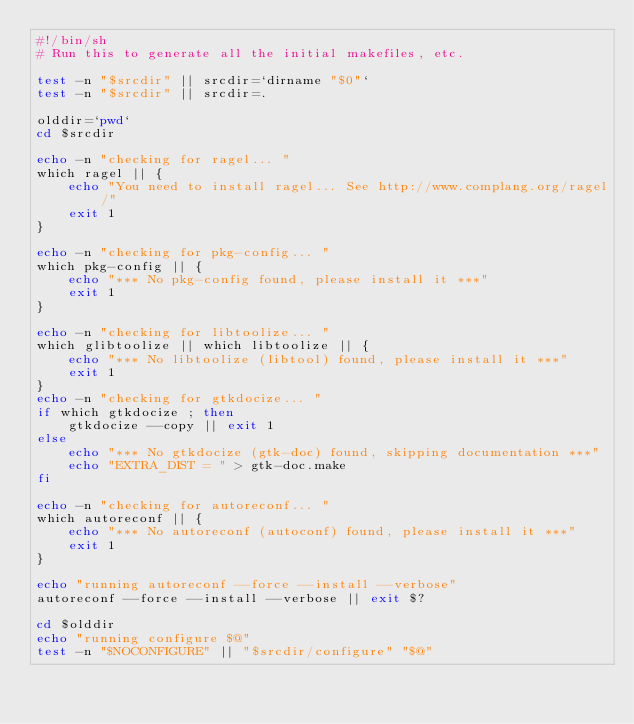Convert code to text. <code><loc_0><loc_0><loc_500><loc_500><_Bash_>#!/bin/sh
# Run this to generate all the initial makefiles, etc.

test -n "$srcdir" || srcdir=`dirname "$0"`
test -n "$srcdir" || srcdir=.

olddir=`pwd`
cd $srcdir

echo -n "checking for ragel... "
which ragel || {
	echo "You need to install ragel... See http://www.complang.org/ragel/"
	exit 1
}

echo -n "checking for pkg-config... "
which pkg-config || {
	echo "*** No pkg-config found, please install it ***"
	exit 1
}

echo -n "checking for libtoolize... "
which glibtoolize || which libtoolize || {
	echo "*** No libtoolize (libtool) found, please install it ***"
	exit 1
}
echo -n "checking for gtkdocize... "
if which gtkdocize ; then
	gtkdocize --copy || exit 1
else
	echo "*** No gtkdocize (gtk-doc) found, skipping documentation ***"
	echo "EXTRA_DIST = " > gtk-doc.make
fi

echo -n "checking for autoreconf... "
which autoreconf || {
	echo "*** No autoreconf (autoconf) found, please install it ***"
	exit 1
}

echo "running autoreconf --force --install --verbose"
autoreconf --force --install --verbose || exit $?

cd $olddir
echo "running configure $@"
test -n "$NOCONFIGURE" || "$srcdir/configure" "$@"
</code> 